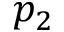<formula> <loc_0><loc_0><loc_500><loc_500>p _ { 2 }</formula> 